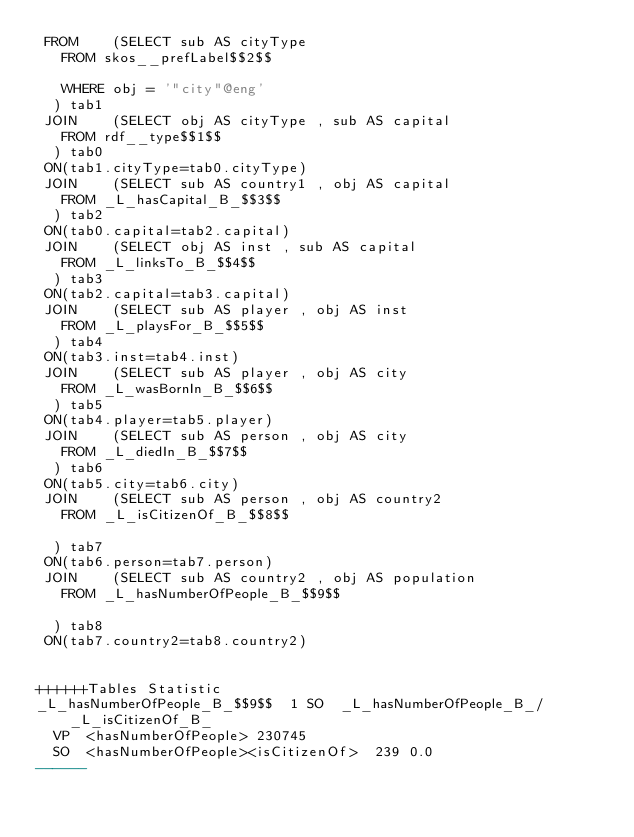Convert code to text. <code><loc_0><loc_0><loc_500><loc_500><_SQL_> FROM    (SELECT sub AS cityType 
	 FROM skos__prefLabel$$2$$
	 
	 WHERE obj = '"city"@eng'
	) tab1
 JOIN    (SELECT obj AS cityType , sub AS capital 
	 FROM rdf__type$$1$$
	) tab0
 ON(tab1.cityType=tab0.cityType)
 JOIN    (SELECT sub AS country1 , obj AS capital 
	 FROM _L_hasCapital_B_$$3$$
	) tab2
 ON(tab0.capital=tab2.capital)
 JOIN    (SELECT obj AS inst , sub AS capital 
	 FROM _L_linksTo_B_$$4$$
	) tab3
 ON(tab2.capital=tab3.capital)
 JOIN    (SELECT sub AS player , obj AS inst 
	 FROM _L_playsFor_B_$$5$$
	) tab4
 ON(tab3.inst=tab4.inst)
 JOIN    (SELECT sub AS player , obj AS city 
	 FROM _L_wasBornIn_B_$$6$$
	) tab5
 ON(tab4.player=tab5.player)
 JOIN    (SELECT sub AS person , obj AS city 
	 FROM _L_diedIn_B_$$7$$
	) tab6
 ON(tab5.city=tab6.city)
 JOIN    (SELECT sub AS person , obj AS country2 
	 FROM _L_isCitizenOf_B_$$8$$
	
	) tab7
 ON(tab6.person=tab7.person)
 JOIN    (SELECT sub AS country2 , obj AS population 
	 FROM _L_hasNumberOfPeople_B_$$9$$
	
	) tab8
 ON(tab7.country2=tab8.country2)


++++++Tables Statistic
_L_hasNumberOfPeople_B_$$9$$	1	SO	_L_hasNumberOfPeople_B_/_L_isCitizenOf_B_
	VP	<hasNumberOfPeople>	230745
	SO	<hasNumberOfPeople><isCitizenOf>	239	0.0
------</code> 